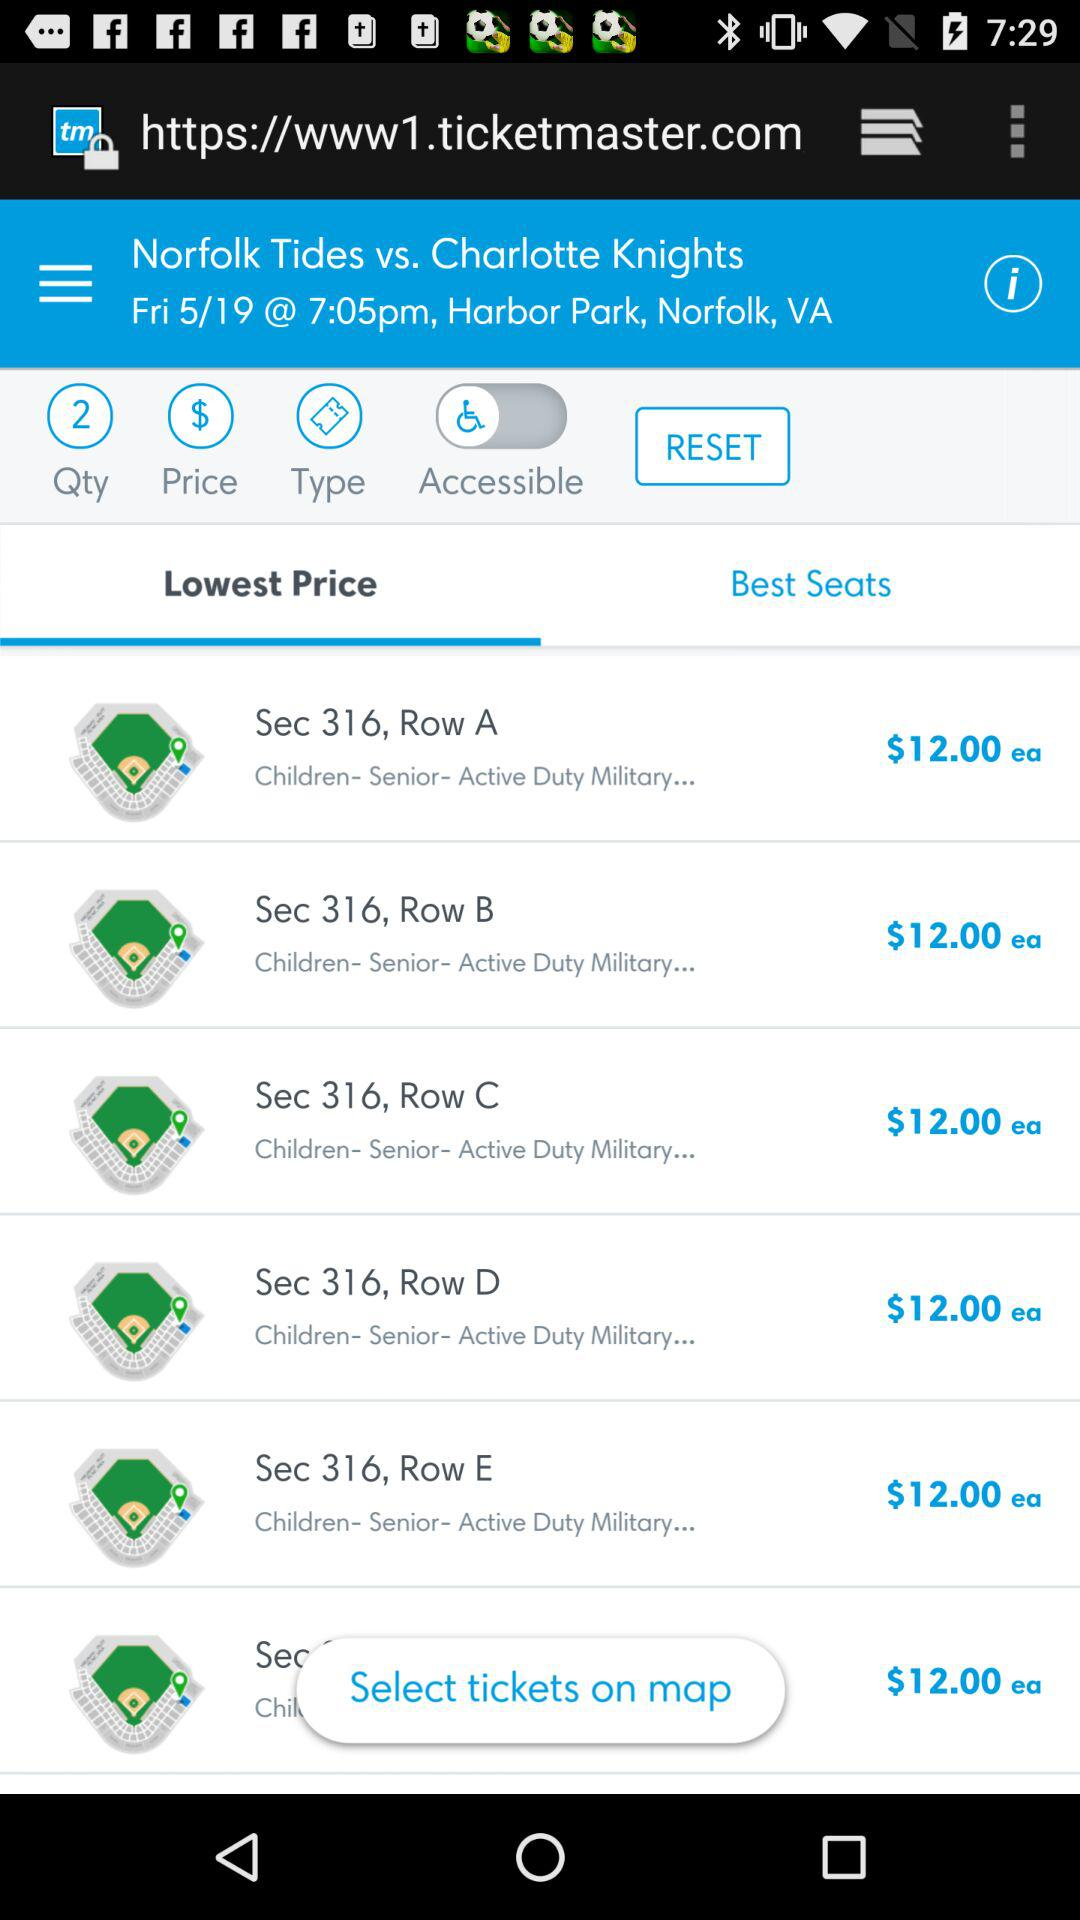How many tickets are available in section 316?
Answer the question using a single word or phrase. 5 